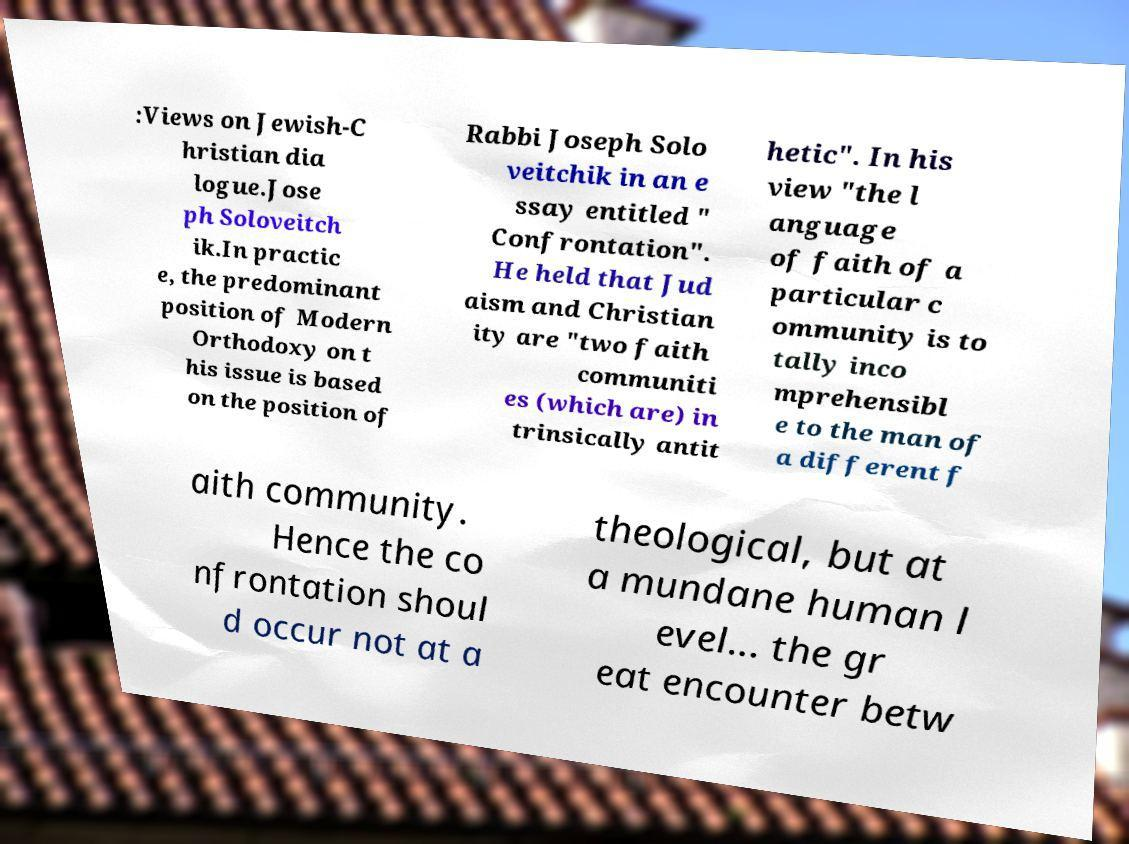Please identify and transcribe the text found in this image. :Views on Jewish-C hristian dia logue.Jose ph Soloveitch ik.In practic e, the predominant position of Modern Orthodoxy on t his issue is based on the position of Rabbi Joseph Solo veitchik in an e ssay entitled " Confrontation". He held that Jud aism and Christian ity are "two faith communiti es (which are) in trinsically antit hetic". In his view "the l anguage of faith of a particular c ommunity is to tally inco mprehensibl e to the man of a different f aith community. Hence the co nfrontation shoul d occur not at a theological, but at a mundane human l evel... the gr eat encounter betw 